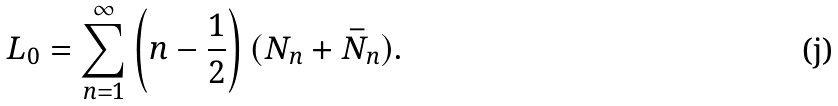<formula> <loc_0><loc_0><loc_500><loc_500>L _ { 0 } = \sum _ { n = 1 } ^ { \infty } \left ( n - \frac { 1 } { 2 } \right ) ( N _ { n } + \bar { N } _ { n } ) .</formula> 